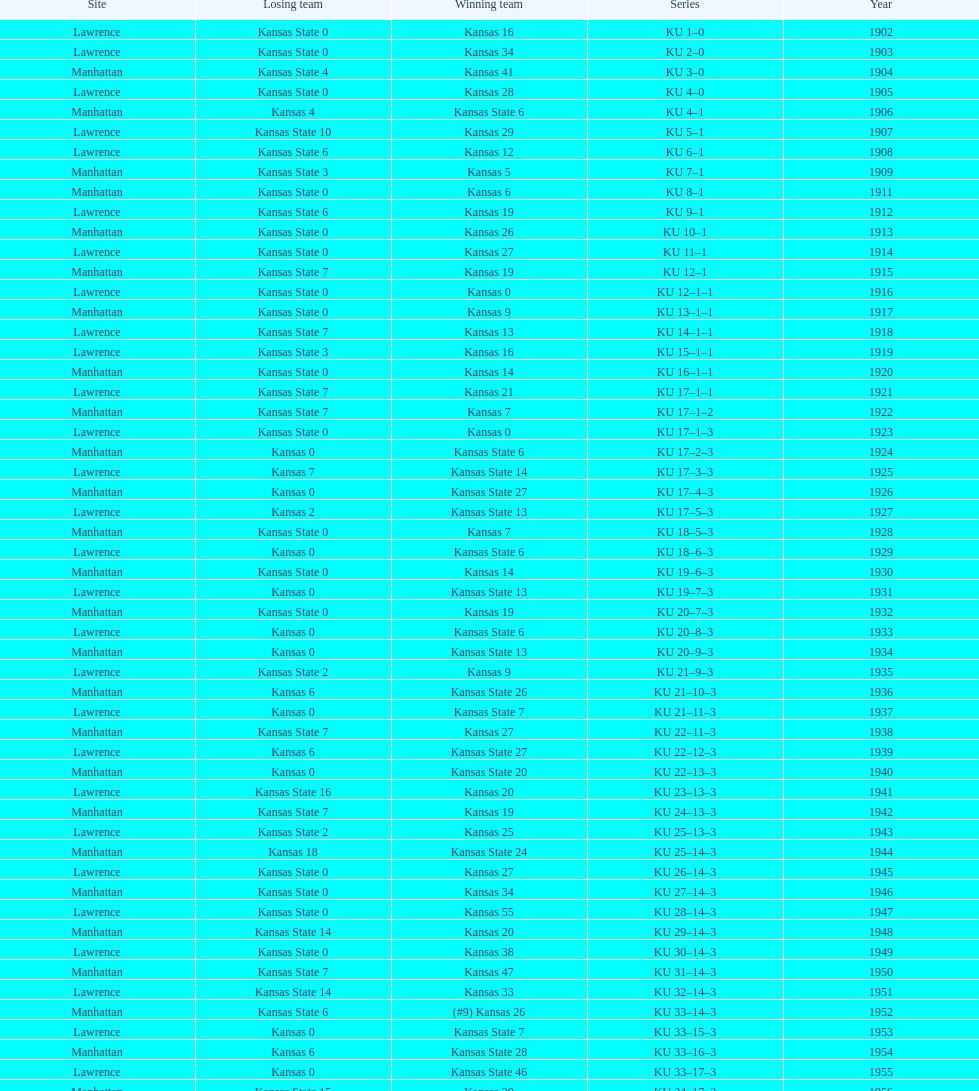How many times did kansas and kansas state play in lawrence from 1902-1968? 34. 